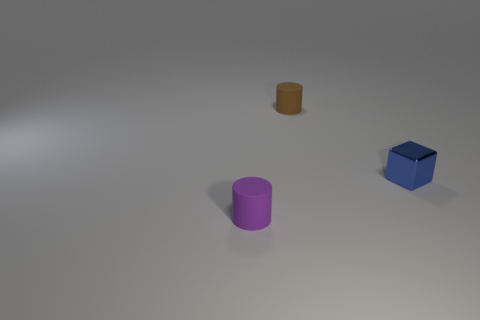What could be the context or purpose of this arrangement of objects? The arrangement of objects may be for a variety of purposes, such as a simple display for an art piece, a setup for a physics experiment about shapes and balance, or perhaps a still life composition for practicing drawing or 3D modeling. Each object's distinct color and shape could be meant to draw attention to their individual characteristics and how they contrast with each other in the scene. 